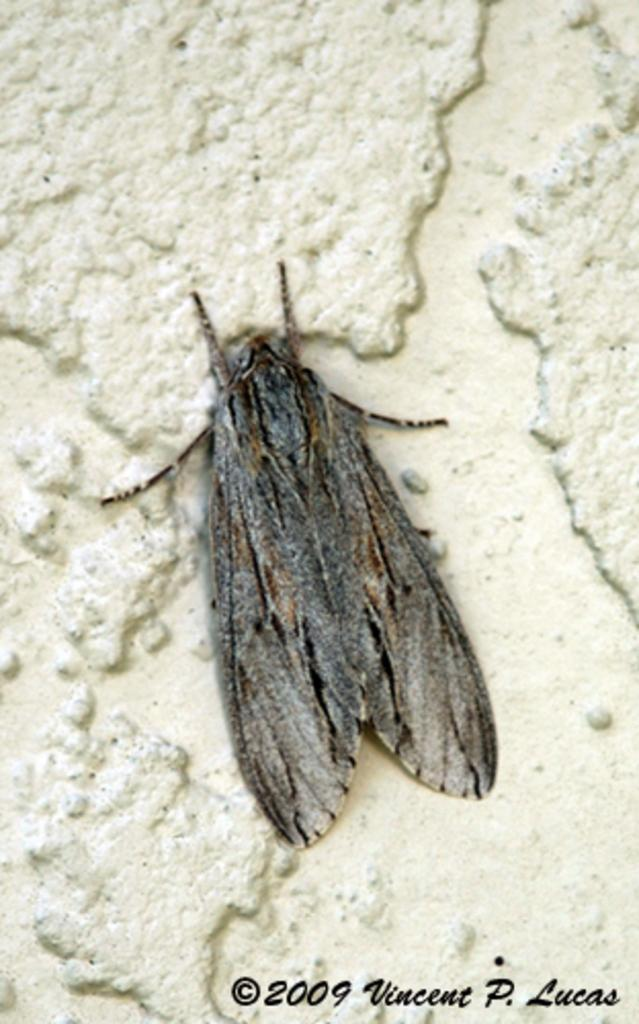What type of creature is in the image? There is an insect in the image. What colors can be seen on the insect? The insect has brown and black colors. Where is the insect located in the image? The insect is on a white wall. What type of oven is visible in the image? There is no oven present in the image; it features an insect on a white wall. What route does the insect take to reach the top of the wall? The image does not show the insect moving or taking a specific route to reach the top of the wall. 